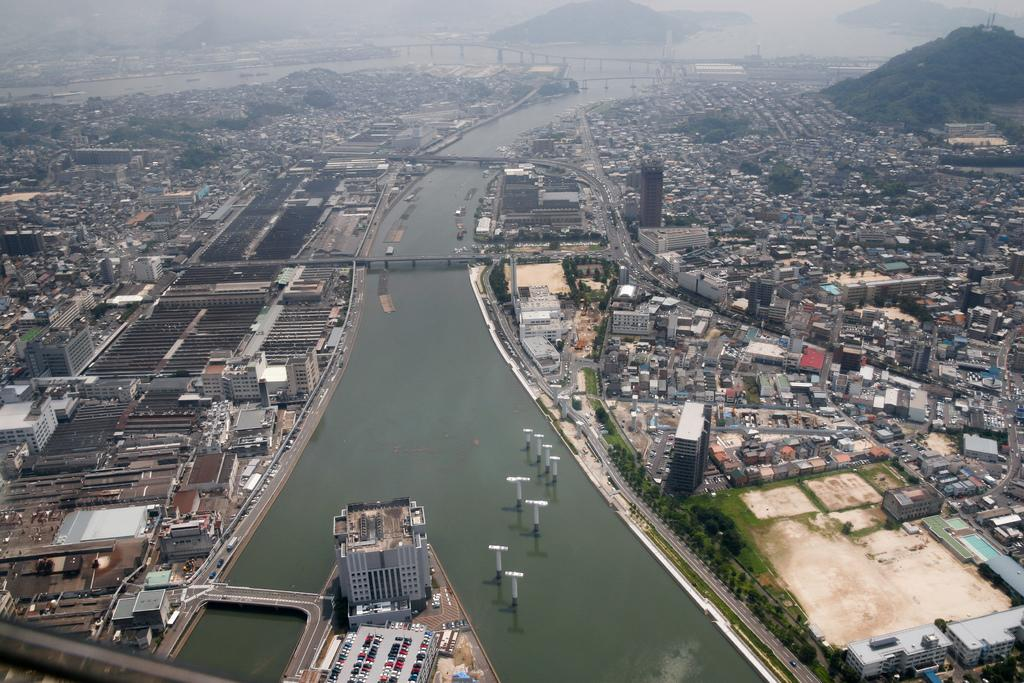What type of structures can be seen in the image? There is a group of buildings and houses in the image. What other elements can be found in the image? Trees, roads, poles, and a water body under the bridges are visible in the image. Can you describe the natural elements in the image? There are trees and a group of trees on the hills in the background of the image. How are the buildings and houses arranged in the image? The buildings and houses are arranged along the roads and near the water body. What type of game is being played on the water body in the image? There is no game being played on the water body in the image; it is a natural water body with bridges crossing over it. 